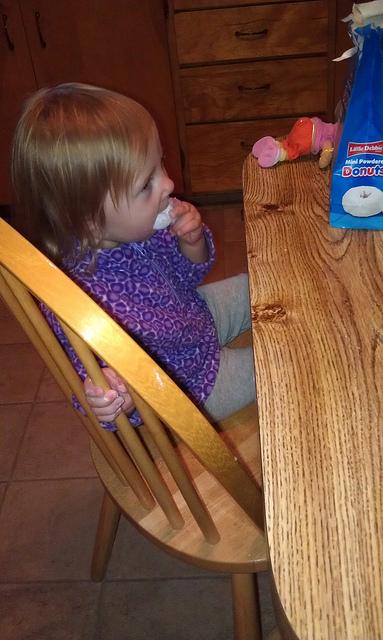What color is the toddler's hair?
Concise answer only. Blonde. What kind of donut does she like?
Answer briefly. Powdered. What is the name of the character lying behind the bag?
Keep it brief. Dora. 